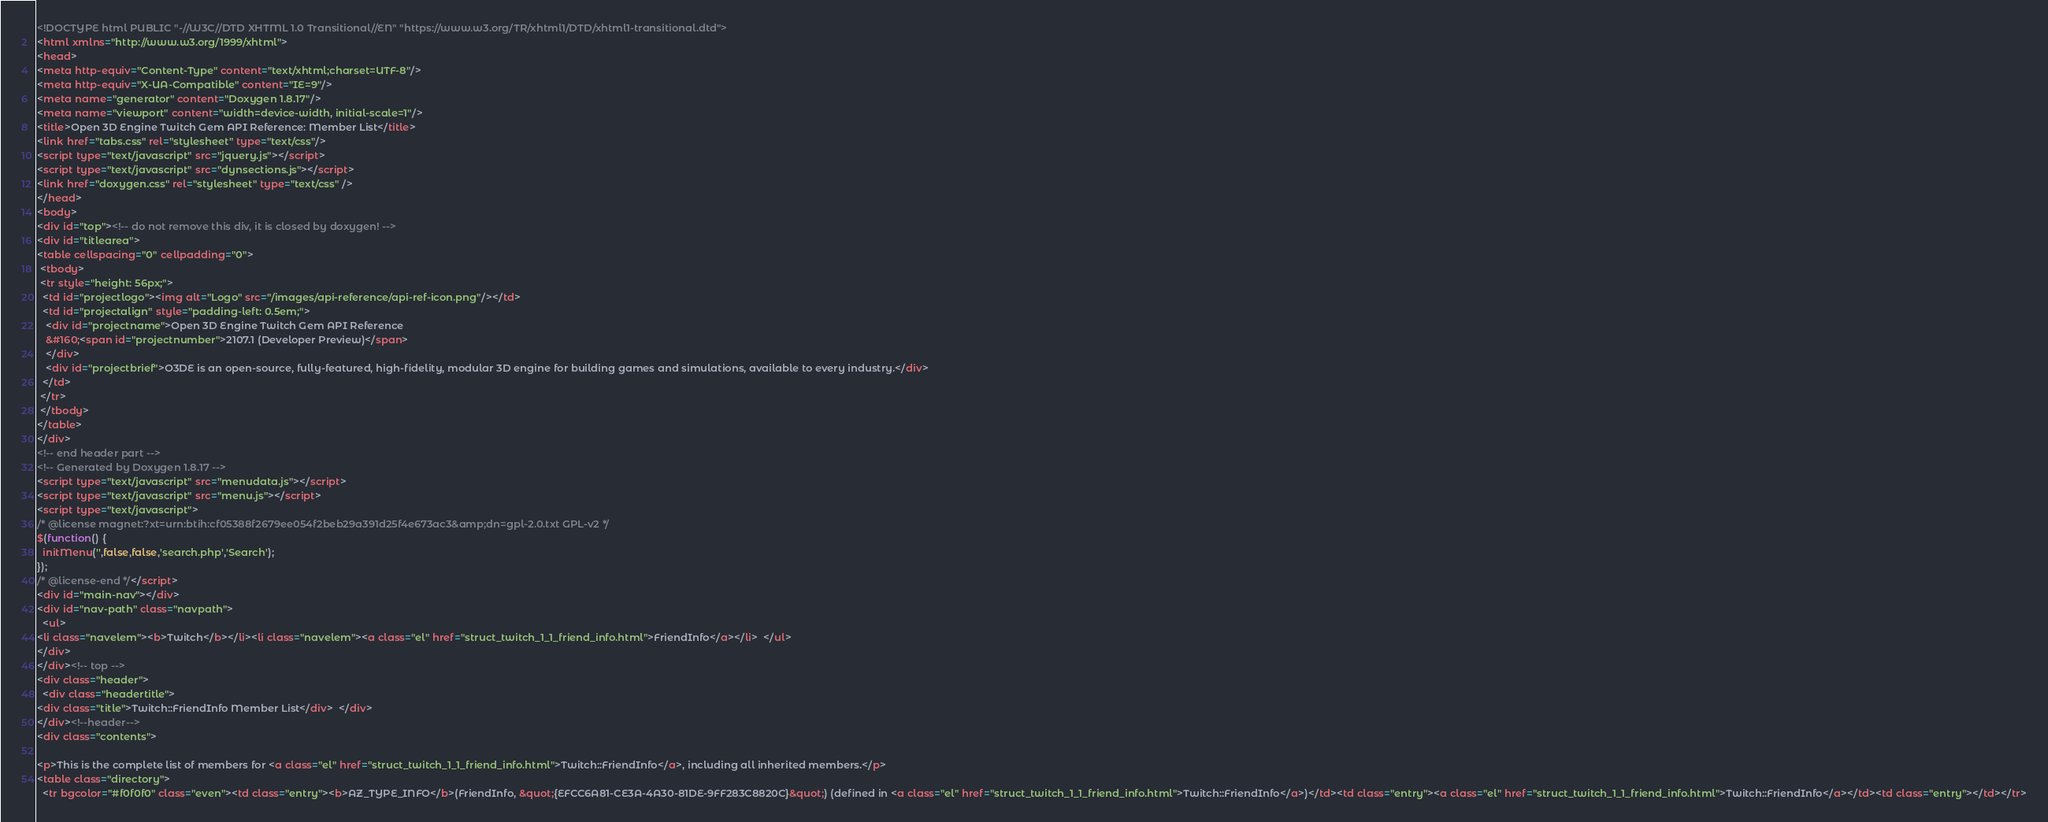Convert code to text. <code><loc_0><loc_0><loc_500><loc_500><_HTML_><!DOCTYPE html PUBLIC "-//W3C//DTD XHTML 1.0 Transitional//EN" "https://www.w3.org/TR/xhtml1/DTD/xhtml1-transitional.dtd">
<html xmlns="http://www.w3.org/1999/xhtml">
<head>
<meta http-equiv="Content-Type" content="text/xhtml;charset=UTF-8"/>
<meta http-equiv="X-UA-Compatible" content="IE=9"/>
<meta name="generator" content="Doxygen 1.8.17"/>
<meta name="viewport" content="width=device-width, initial-scale=1"/>
<title>Open 3D Engine Twitch Gem API Reference: Member List</title>
<link href="tabs.css" rel="stylesheet" type="text/css"/>
<script type="text/javascript" src="jquery.js"></script>
<script type="text/javascript" src="dynsections.js"></script>
<link href="doxygen.css" rel="stylesheet" type="text/css" />
</head>
<body>
<div id="top"><!-- do not remove this div, it is closed by doxygen! -->
<div id="titlearea">
<table cellspacing="0" cellpadding="0">
 <tbody>
 <tr style="height: 56px;">
  <td id="projectlogo"><img alt="Logo" src="/images/api-reference/api-ref-icon.png"/></td>
  <td id="projectalign" style="padding-left: 0.5em;">
   <div id="projectname">Open 3D Engine Twitch Gem API Reference
   &#160;<span id="projectnumber">2107.1 (Developer Preview)</span>
   </div>
   <div id="projectbrief">O3DE is an open-source, fully-featured, high-fidelity, modular 3D engine for building games and simulations, available to every industry.</div>
  </td>
 </tr>
 </tbody>
</table>
</div>
<!-- end header part -->
<!-- Generated by Doxygen 1.8.17 -->
<script type="text/javascript" src="menudata.js"></script>
<script type="text/javascript" src="menu.js"></script>
<script type="text/javascript">
/* @license magnet:?xt=urn:btih:cf05388f2679ee054f2beb29a391d25f4e673ac3&amp;dn=gpl-2.0.txt GPL-v2 */
$(function() {
  initMenu('',false,false,'search.php','Search');
});
/* @license-end */</script>
<div id="main-nav"></div>
<div id="nav-path" class="navpath">
  <ul>
<li class="navelem"><b>Twitch</b></li><li class="navelem"><a class="el" href="struct_twitch_1_1_friend_info.html">FriendInfo</a></li>  </ul>
</div>
</div><!-- top -->
<div class="header">
  <div class="headertitle">
<div class="title">Twitch::FriendInfo Member List</div>  </div>
</div><!--header-->
<div class="contents">

<p>This is the complete list of members for <a class="el" href="struct_twitch_1_1_friend_info.html">Twitch::FriendInfo</a>, including all inherited members.</p>
<table class="directory">
  <tr bgcolor="#f0f0f0" class="even"><td class="entry"><b>AZ_TYPE_INFO</b>(FriendInfo, &quot;{EFCC6A81-CE3A-4A30-81DE-9FF283C8820C}&quot;) (defined in <a class="el" href="struct_twitch_1_1_friend_info.html">Twitch::FriendInfo</a>)</td><td class="entry"><a class="el" href="struct_twitch_1_1_friend_info.html">Twitch::FriendInfo</a></td><td class="entry"></td></tr></code> 